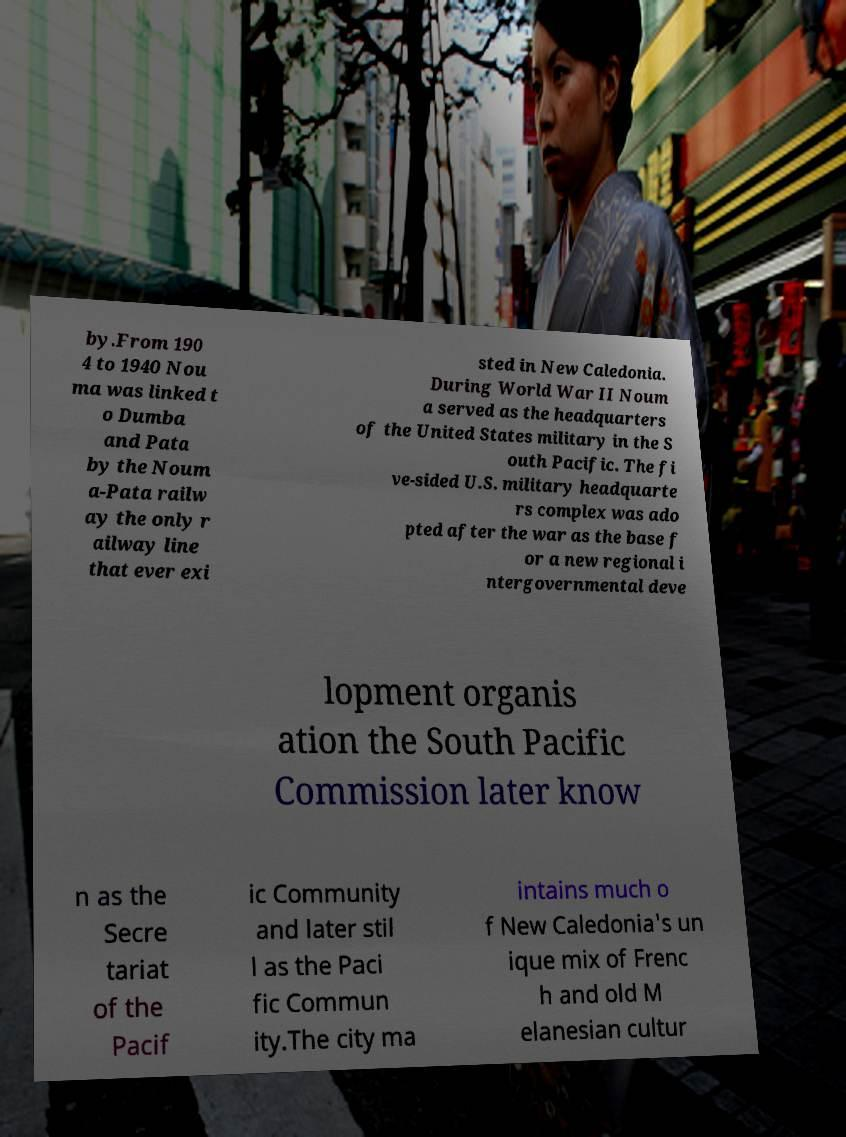I need the written content from this picture converted into text. Can you do that? by.From 190 4 to 1940 Nou ma was linked t o Dumba and Pata by the Noum a-Pata railw ay the only r ailway line that ever exi sted in New Caledonia. During World War II Noum a served as the headquarters of the United States military in the S outh Pacific. The fi ve-sided U.S. military headquarte rs complex was ado pted after the war as the base f or a new regional i ntergovernmental deve lopment organis ation the South Pacific Commission later know n as the Secre tariat of the Pacif ic Community and later stil l as the Paci fic Commun ity.The city ma intains much o f New Caledonia's un ique mix of Frenc h and old M elanesian cultur 